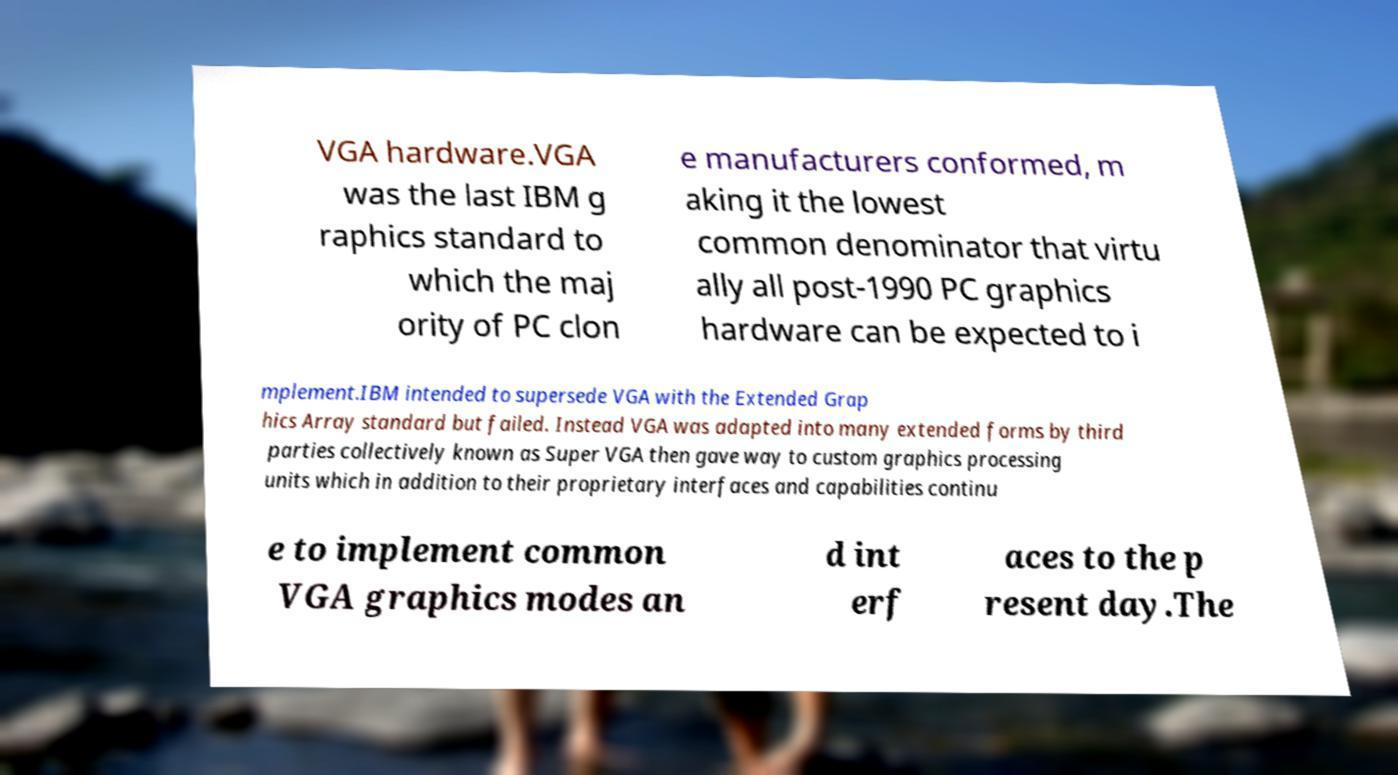Please read and relay the text visible in this image. What does it say? VGA hardware.VGA was the last IBM g raphics standard to which the maj ority of PC clon e manufacturers conformed, m aking it the lowest common denominator that virtu ally all post-1990 PC graphics hardware can be expected to i mplement.IBM intended to supersede VGA with the Extended Grap hics Array standard but failed. Instead VGA was adapted into many extended forms by third parties collectively known as Super VGA then gave way to custom graphics processing units which in addition to their proprietary interfaces and capabilities continu e to implement common VGA graphics modes an d int erf aces to the p resent day.The 